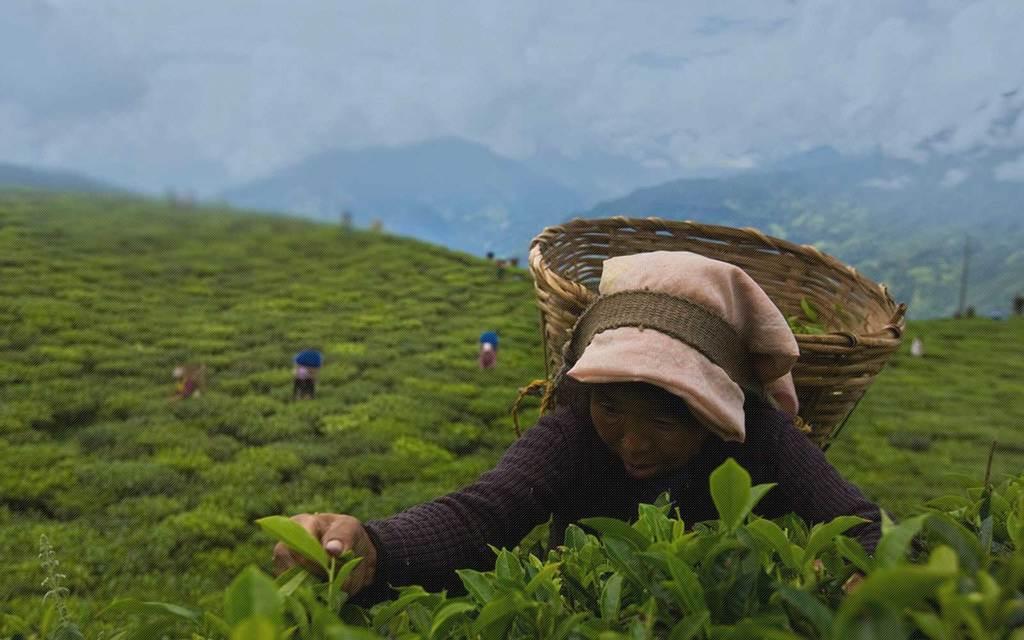How would you summarize this image in a sentence or two? In this picture we can see some people and a woman with a basket. Behind the people there are trees, hills and the sky. 